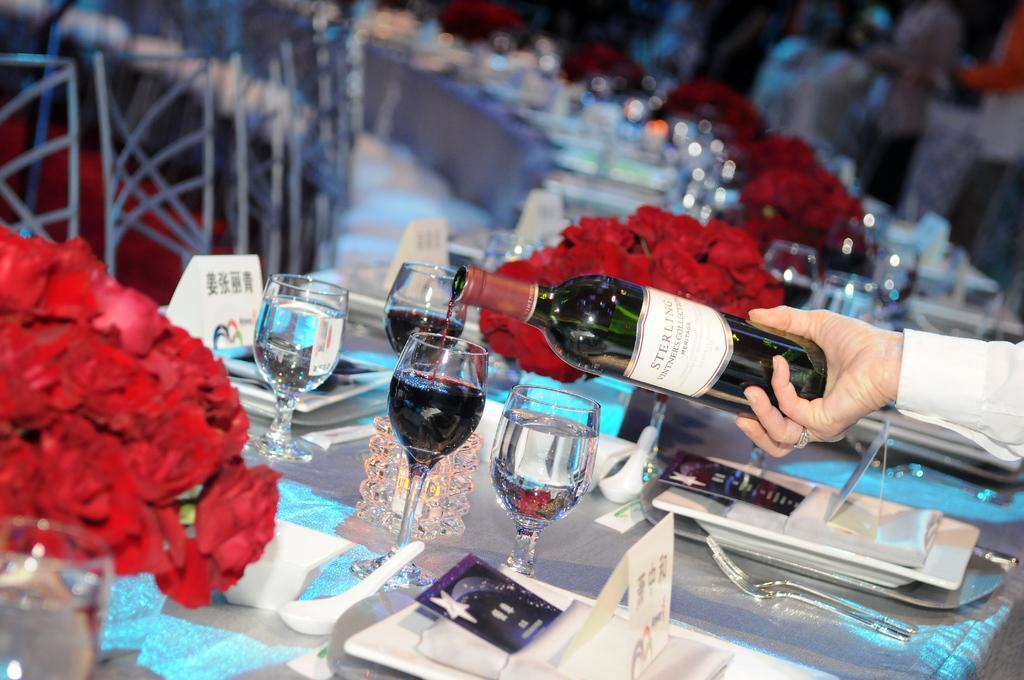Describe this image in one or two sentences. there is a table on which there are glasses, red roses, spoon, plate, white napkin, fork. at the right a person is holding a green glass and pouring the drink in the glass. he is wearing white shirt. at the left there are chairs arranged in front of the table. 